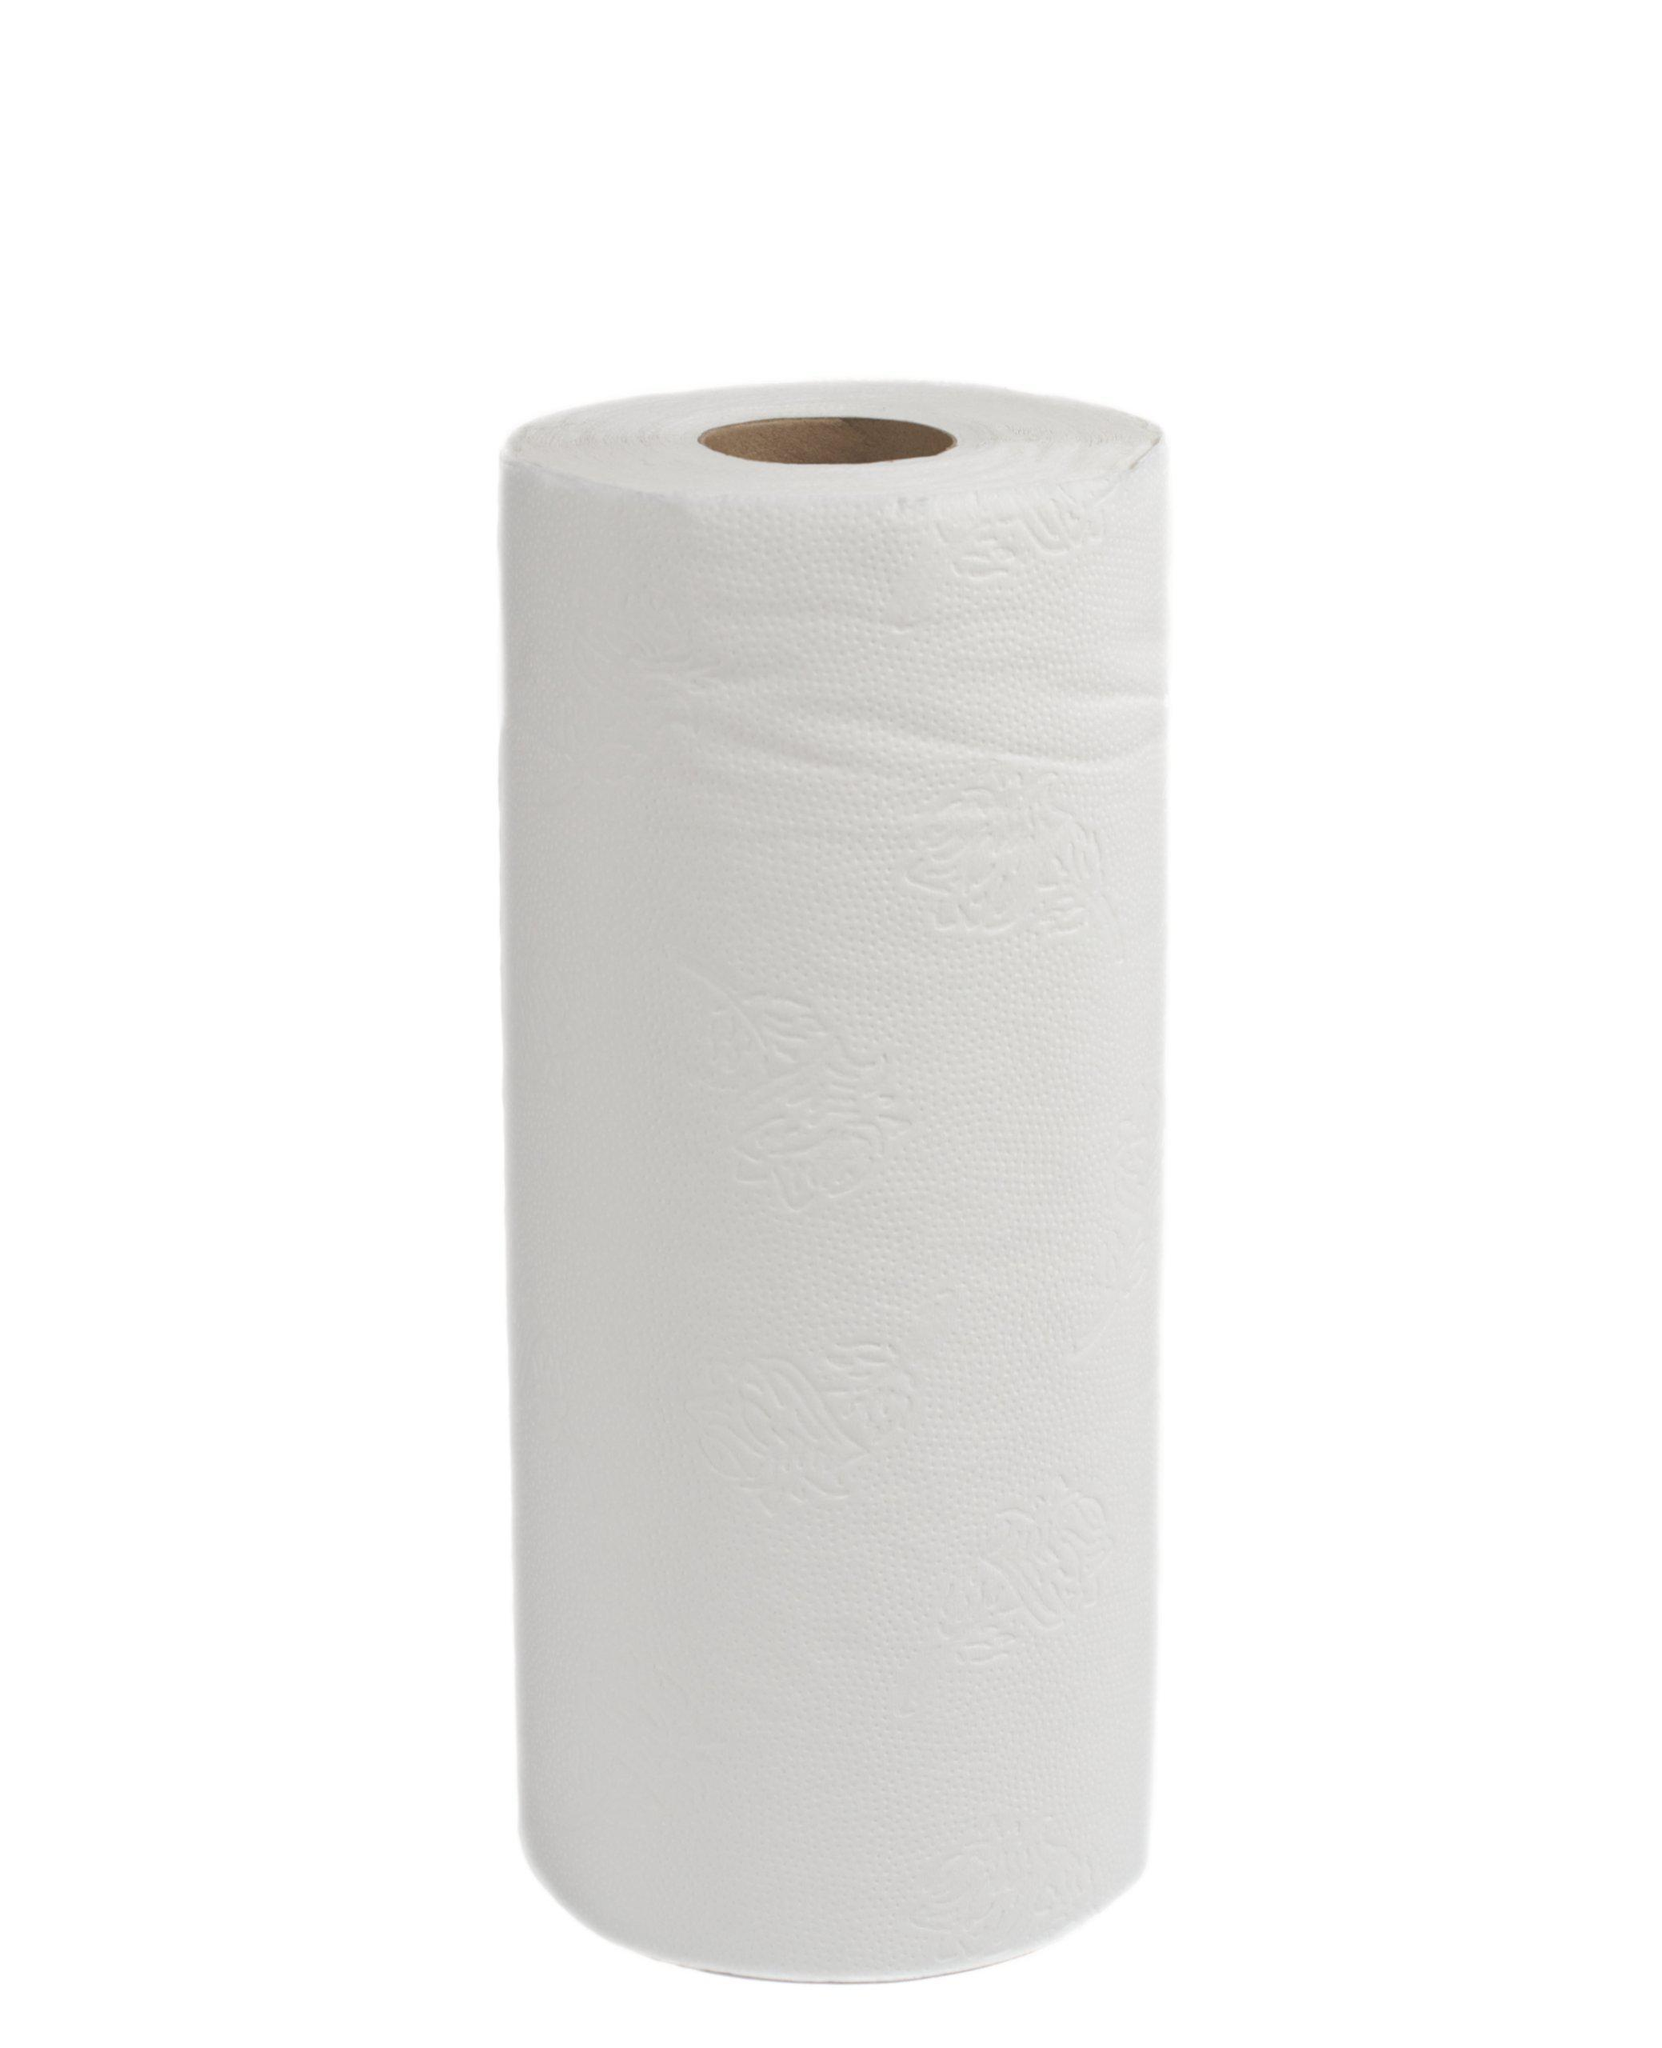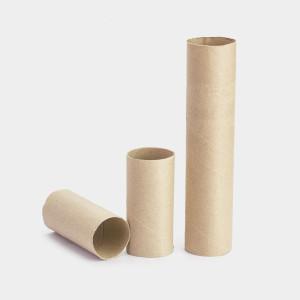The first image is the image on the left, the second image is the image on the right. Considering the images on both sides, is "Exactly two rolls of white paper towels are standing upright." valid? Answer yes or no. No. The first image is the image on the left, the second image is the image on the right. For the images shown, is this caption "there are exactly two rolls of paper in the image on the left" true? Answer yes or no. No. 